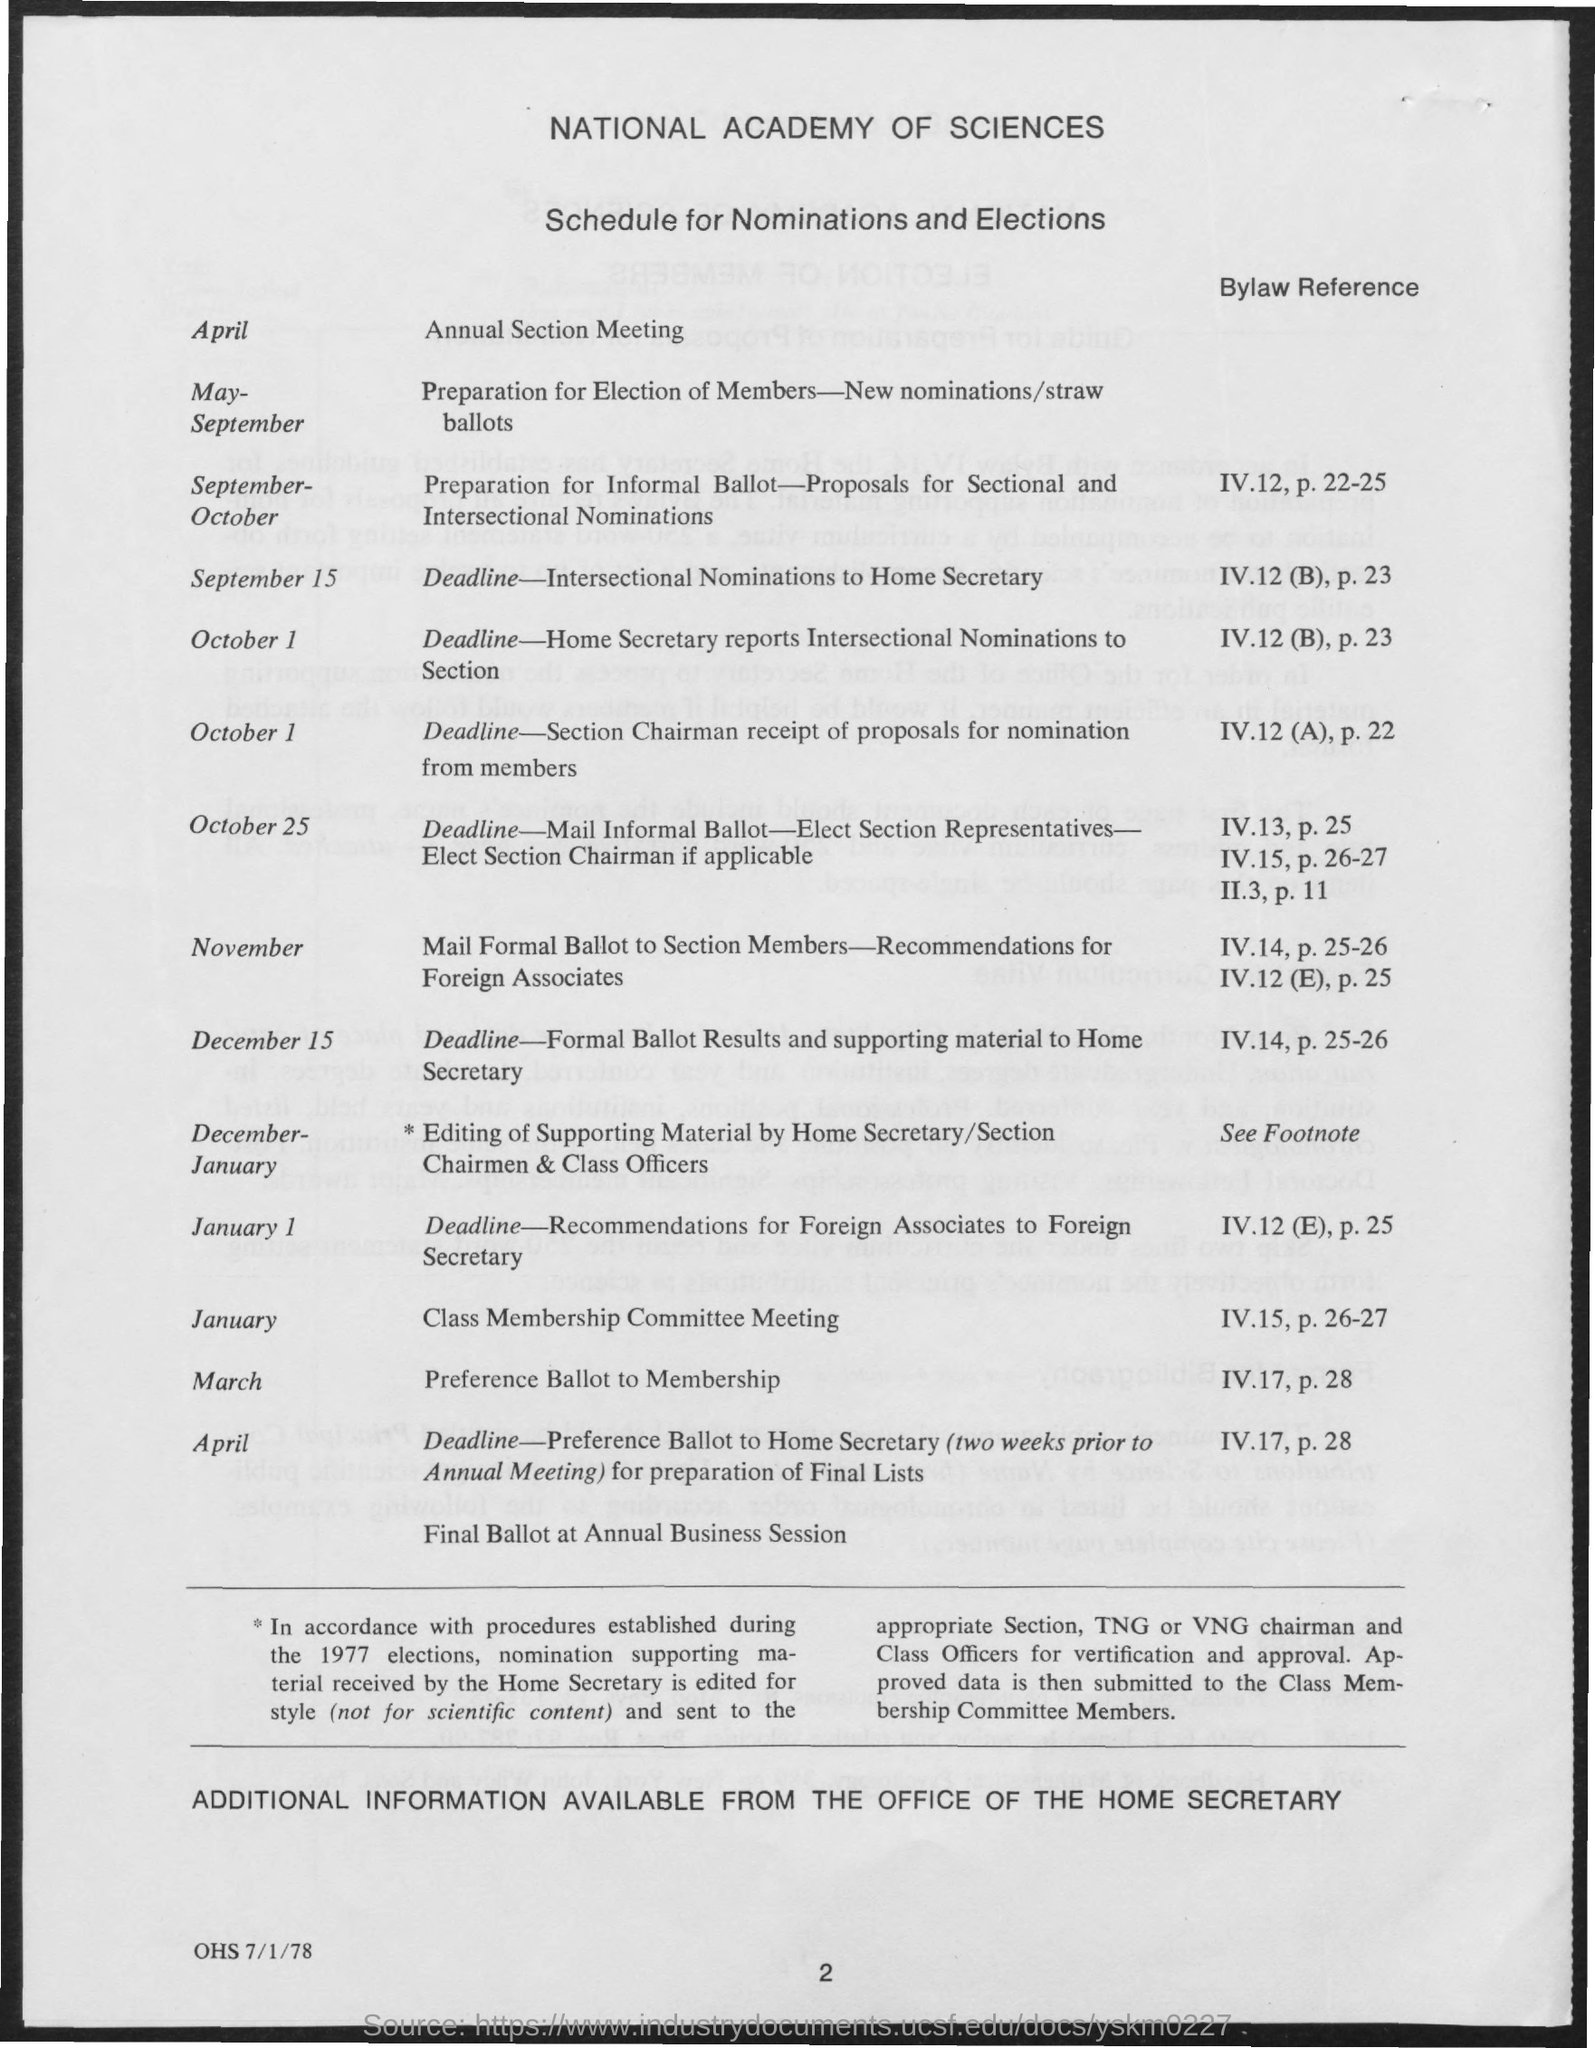In which month annual section meeting is scheduled ?
Keep it short and to the point. April. When is the class membership committee meeting is scheduled ?
Provide a short and direct response. January. What is the deadline time for the section chairman receipt of proposals for nomination from members ?
Your answer should be compact. October 1. What is the schedule in the month of march  ?
Your answer should be compact. Preference ballot to membership. What is the schedule given for the months of may - september ?
Offer a terse response. Preparation for election of members-new nominations/straw ballots. What is the schedule given for the month of november ?
Your answer should be compact. Mail formal ballot to section members-recommendations for foreign associates. 